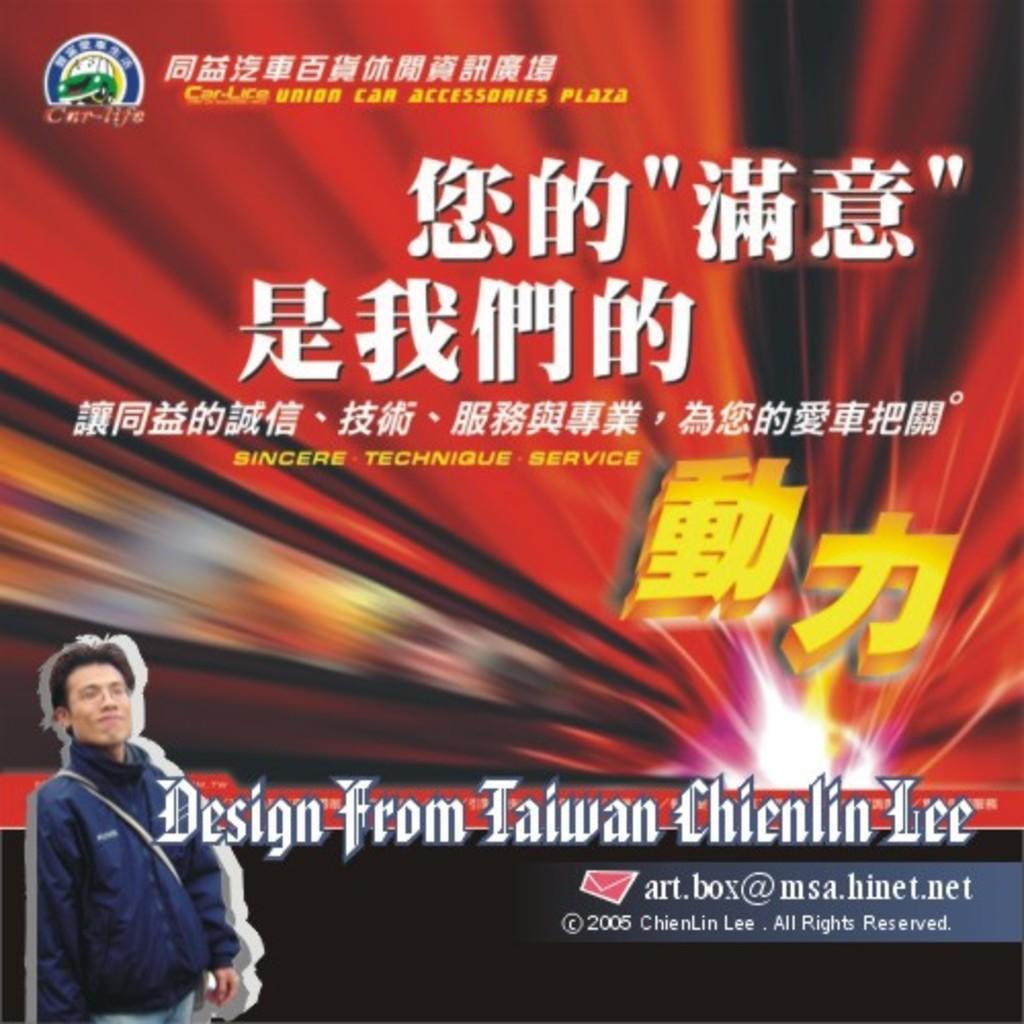Please provide a concise description of this image. On the bottom left corner there is a man who is wearing spectacles, jacket, bag and jeans. Here we can see poster on which something is written. 